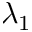Convert formula to latex. <formula><loc_0><loc_0><loc_500><loc_500>\lambda _ { 1 }</formula> 